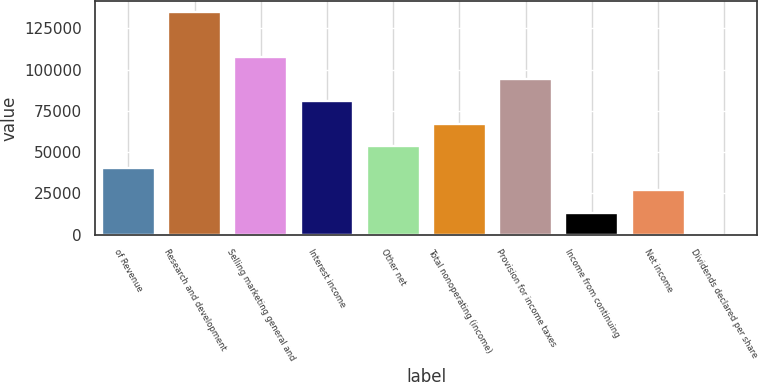Convert chart to OTSL. <chart><loc_0><loc_0><loc_500><loc_500><bar_chart><fcel>of Revenue<fcel>Research and development<fcel>Selling marketing general and<fcel>Interest income<fcel>Other net<fcel>Total nonoperating (income)<fcel>Provision for income taxes<fcel>Income from continuing<fcel>Net income<fcel>Dividends declared per share<nl><fcel>40396<fcel>134653<fcel>107722<fcel>80791.9<fcel>53861.3<fcel>67326.6<fcel>94257.1<fcel>13465.5<fcel>26930.7<fcel>0.18<nl></chart> 